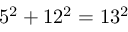Convert formula to latex. <formula><loc_0><loc_0><loc_500><loc_500>5 ^ { 2 } + 1 2 ^ { 2 } = 1 3 ^ { 2 }</formula> 